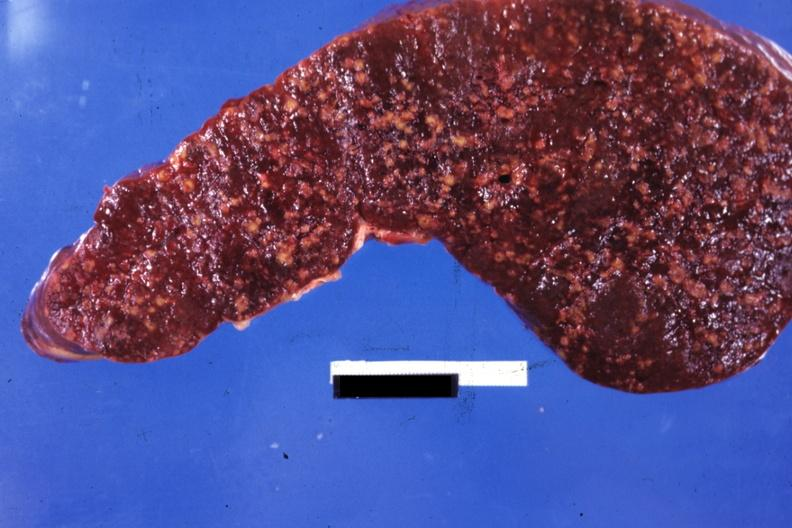s malignant histiocytosis present?
Answer the question using a single word or phrase. Yes 